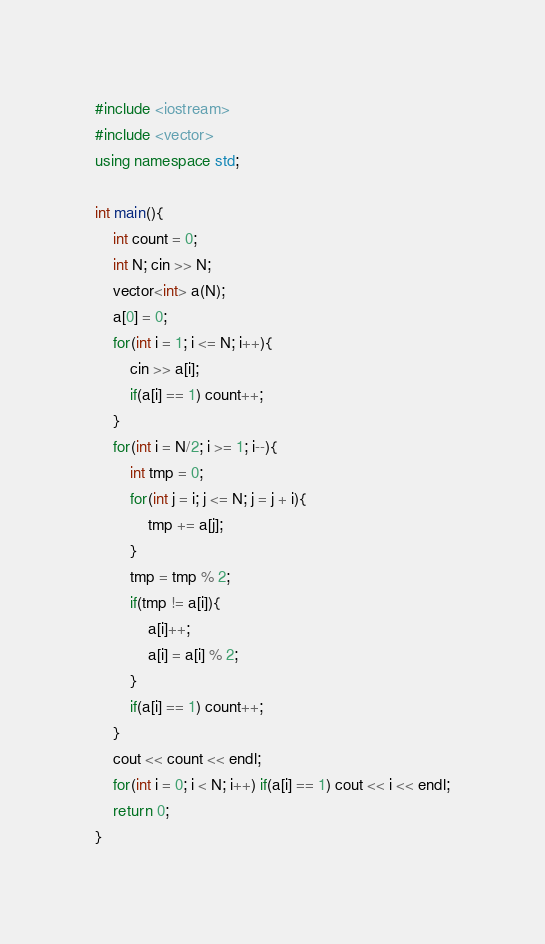Convert code to text. <code><loc_0><loc_0><loc_500><loc_500><_C++_>#include <iostream>
#include <vector>
using namespace std;
 
int main(){
  	int count = 0;
    int N; cin >> N;
    vector<int> a(N);
    a[0] = 0;
    for(int i = 1; i <= N; i++){
        cin >> a[i];
      	if(a[i] == 1) count++;
    }
    for(int i = N/2; i >= 1; i--){
        int tmp = 0;
        for(int j = i; j <= N; j = j + i){
            tmp += a[j];
        }
        tmp = tmp % 2;
        if(tmp != a[i]){
            a[i]++;
            a[i] = a[i] % 2;
        }
        if(a[i] == 1) count++;
    }
    cout << count << endl;
    for(int i = 0; i < N; i++) if(a[i] == 1) cout << i << endl;
    return 0;
}</code> 